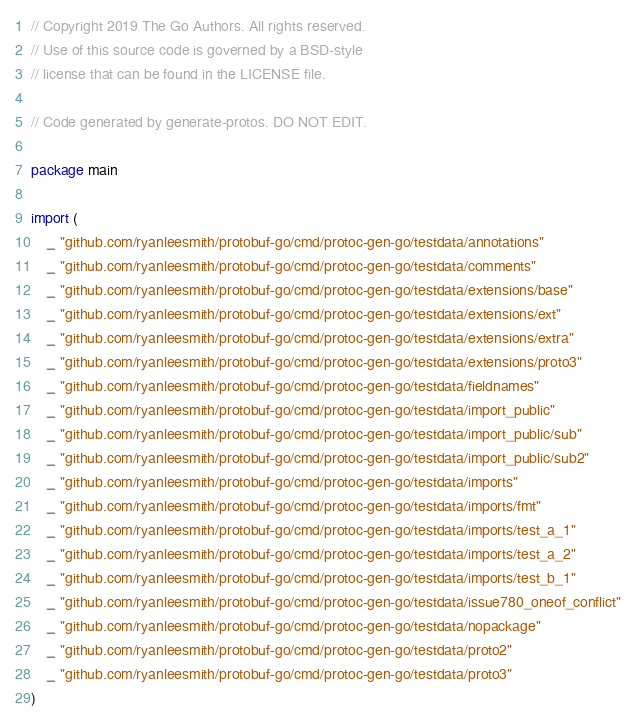<code> <loc_0><loc_0><loc_500><loc_500><_Go_>// Copyright 2019 The Go Authors. All rights reserved.
// Use of this source code is governed by a BSD-style
// license that can be found in the LICENSE file.

// Code generated by generate-protos. DO NOT EDIT.

package main

import (
	_ "github.com/ryanleesmith/protobuf-go/cmd/protoc-gen-go/testdata/annotations"
	_ "github.com/ryanleesmith/protobuf-go/cmd/protoc-gen-go/testdata/comments"
	_ "github.com/ryanleesmith/protobuf-go/cmd/protoc-gen-go/testdata/extensions/base"
	_ "github.com/ryanleesmith/protobuf-go/cmd/protoc-gen-go/testdata/extensions/ext"
	_ "github.com/ryanleesmith/protobuf-go/cmd/protoc-gen-go/testdata/extensions/extra"
	_ "github.com/ryanleesmith/protobuf-go/cmd/protoc-gen-go/testdata/extensions/proto3"
	_ "github.com/ryanleesmith/protobuf-go/cmd/protoc-gen-go/testdata/fieldnames"
	_ "github.com/ryanleesmith/protobuf-go/cmd/protoc-gen-go/testdata/import_public"
	_ "github.com/ryanleesmith/protobuf-go/cmd/protoc-gen-go/testdata/import_public/sub"
	_ "github.com/ryanleesmith/protobuf-go/cmd/protoc-gen-go/testdata/import_public/sub2"
	_ "github.com/ryanleesmith/protobuf-go/cmd/protoc-gen-go/testdata/imports"
	_ "github.com/ryanleesmith/protobuf-go/cmd/protoc-gen-go/testdata/imports/fmt"
	_ "github.com/ryanleesmith/protobuf-go/cmd/protoc-gen-go/testdata/imports/test_a_1"
	_ "github.com/ryanleesmith/protobuf-go/cmd/protoc-gen-go/testdata/imports/test_a_2"
	_ "github.com/ryanleesmith/protobuf-go/cmd/protoc-gen-go/testdata/imports/test_b_1"
	_ "github.com/ryanleesmith/protobuf-go/cmd/protoc-gen-go/testdata/issue780_oneof_conflict"
	_ "github.com/ryanleesmith/protobuf-go/cmd/protoc-gen-go/testdata/nopackage"
	_ "github.com/ryanleesmith/protobuf-go/cmd/protoc-gen-go/testdata/proto2"
	_ "github.com/ryanleesmith/protobuf-go/cmd/protoc-gen-go/testdata/proto3"
)
</code> 